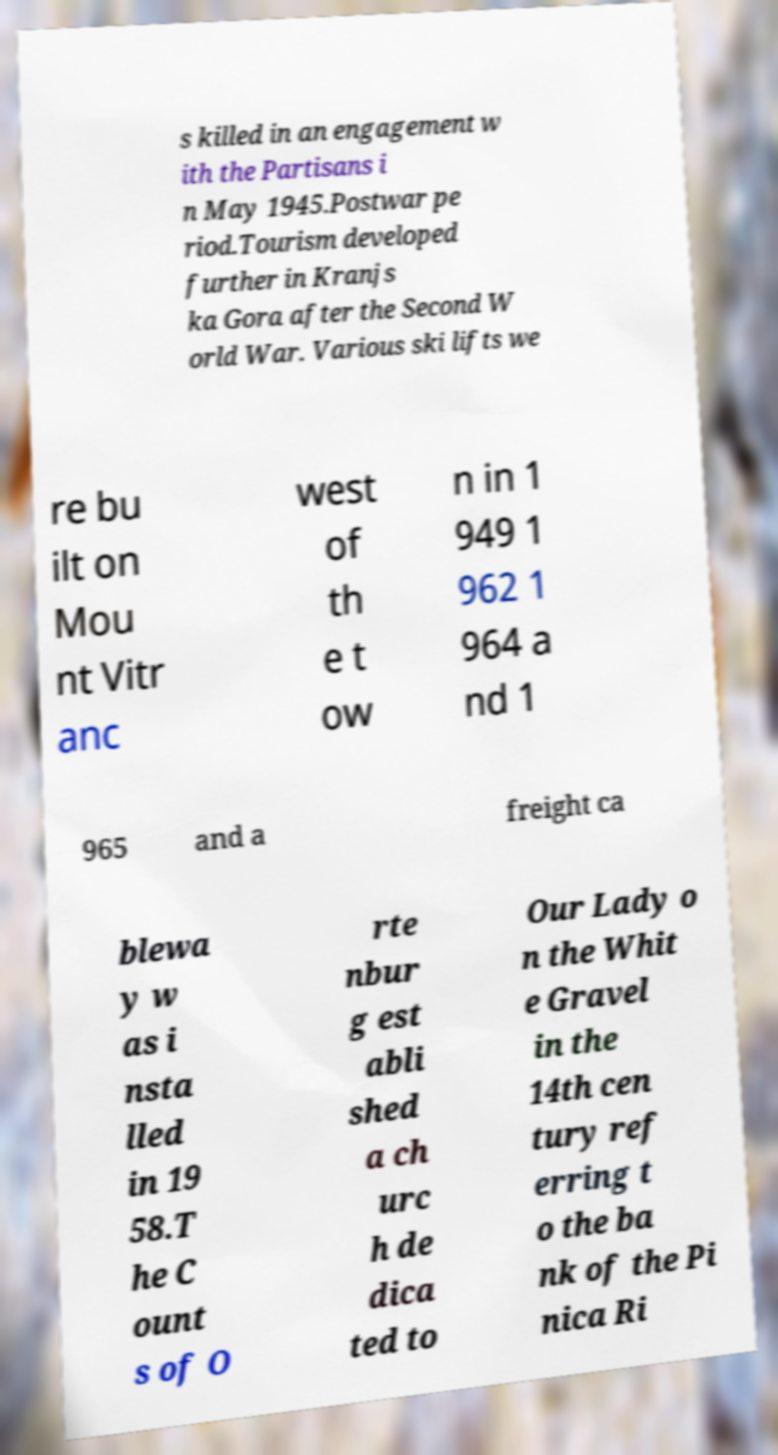Please read and relay the text visible in this image. What does it say? s killed in an engagement w ith the Partisans i n May 1945.Postwar pe riod.Tourism developed further in Kranjs ka Gora after the Second W orld War. Various ski lifts we re bu ilt on Mou nt Vitr anc west of th e t ow n in 1 949 1 962 1 964 a nd 1 965 and a freight ca blewa y w as i nsta lled in 19 58.T he C ount s of O rte nbur g est abli shed a ch urc h de dica ted to Our Lady o n the Whit e Gravel in the 14th cen tury ref erring t o the ba nk of the Pi nica Ri 